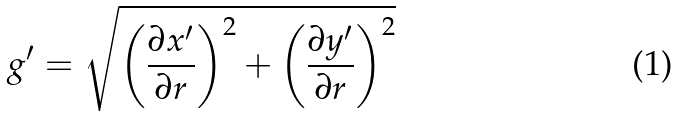<formula> <loc_0><loc_0><loc_500><loc_500>g ^ { \prime } = \sqrt { \left ( \frac { \partial x ^ { \prime } } { \partial r } \right ) ^ { 2 } + \left ( \frac { \partial y ^ { \prime } } { \partial r } \right ) ^ { 2 } }</formula> 